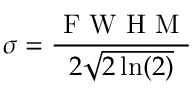Convert formula to latex. <formula><loc_0><loc_0><loc_500><loc_500>\sigma = \frac { F W H M } { 2 \sqrt { 2 \ln ( 2 ) } }</formula> 